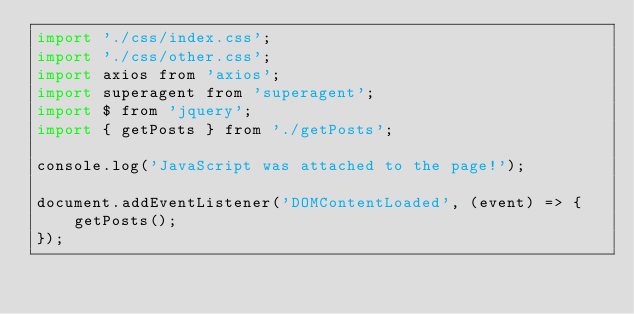Convert code to text. <code><loc_0><loc_0><loc_500><loc_500><_JavaScript_>import './css/index.css';
import './css/other.css';
import axios from 'axios';
import superagent from 'superagent';
import $ from 'jquery';
import { getPosts } from './getPosts';

console.log('JavaScript was attached to the page!');

document.addEventListener('DOMContentLoaded', (event) => {
    getPosts();
});</code> 